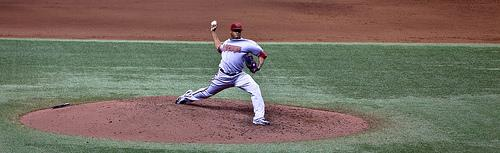What is the color of the player's pants and what is he about to do? The player's pants are white, and he is about to throw the ball. State the time of day during which the photo was taken based on the image information. The photo was taken during the day. What color is the player's cap and what type of sport is he participating in? The cap is red, and he is participating in baseball. What type of ground is shown in the picture? Mention the color of the grass. The ground is sandy, and the grass is green in color. Is the player performing a complex reasoning task or an image context analysis task in the image? Not applicable, as the directions refer to tasks for analysing the image, not the player's actions. Describe the man's stance in the picture, focusing on his legs. The man has his legs stretched and apart, possibly in a throwing stance. What action is the main subject performing in this photograph? The man is holding a baseball and preparing to throw it. Find the color of the tennis ball in the image and mention the color of the man's jersey. The tennis ball is white, and the man's jersey is also white. Identify an accessory the baseball player is wearing and describe its appearance. The player is wearing a red baseball cap with a curved brim. What color is the object the player is holding, and what is its shape? The object is white and round, resembling a baseball. 